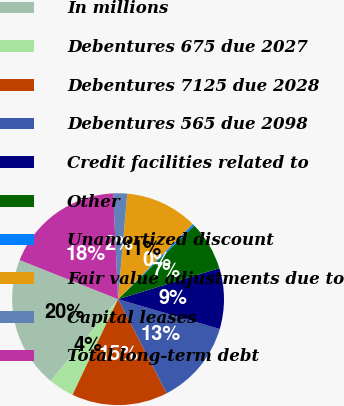<chart> <loc_0><loc_0><loc_500><loc_500><pie_chart><fcel>In millions<fcel>Debentures 675 due 2027<fcel>Debentures 7125 due 2028<fcel>Debentures 565 due 2098<fcel>Credit facilities related to<fcel>Other<fcel>Unamortized discount<fcel>Fair value adjustments due to<fcel>Capital leases<fcel>Total long-term debt<nl><fcel>20.04%<fcel>3.9%<fcel>14.66%<fcel>12.87%<fcel>9.28%<fcel>7.49%<fcel>0.32%<fcel>11.08%<fcel>2.11%<fcel>18.25%<nl></chart> 